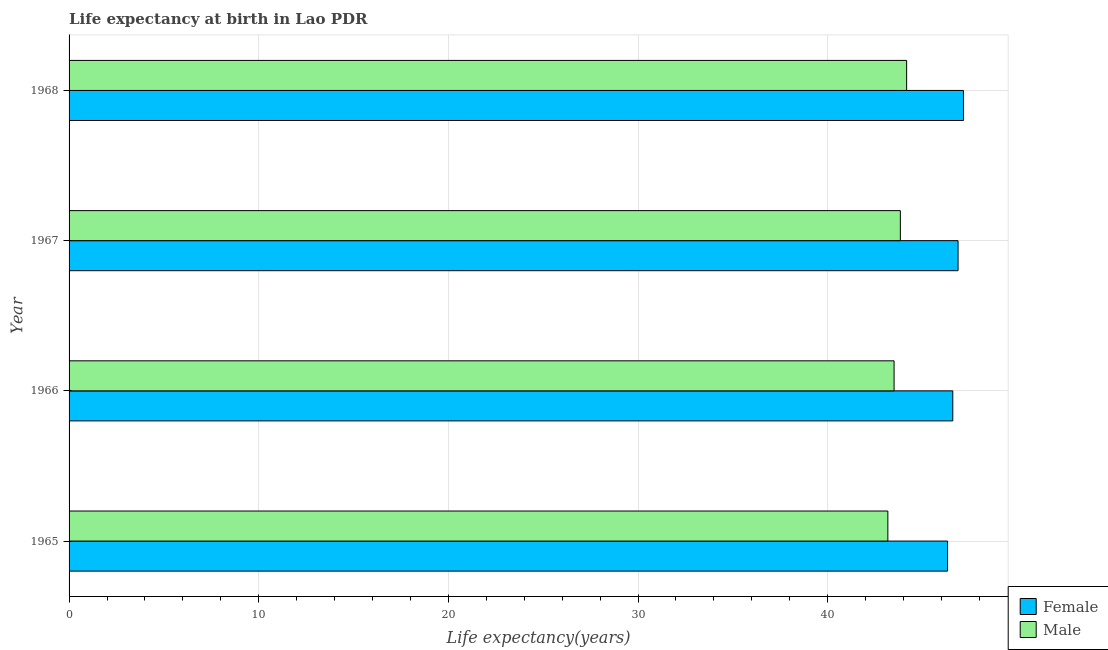How many different coloured bars are there?
Provide a short and direct response. 2. Are the number of bars per tick equal to the number of legend labels?
Offer a terse response. Yes. Are the number of bars on each tick of the Y-axis equal?
Offer a very short reply. Yes. What is the label of the 1st group of bars from the top?
Keep it short and to the point. 1968. In how many cases, is the number of bars for a given year not equal to the number of legend labels?
Make the answer very short. 0. What is the life expectancy(male) in 1968?
Your answer should be compact. 44.16. Across all years, what is the maximum life expectancy(female)?
Your response must be concise. 47.16. Across all years, what is the minimum life expectancy(female)?
Your answer should be compact. 46.32. In which year was the life expectancy(female) maximum?
Provide a short and direct response. 1968. In which year was the life expectancy(female) minimum?
Give a very brief answer. 1965. What is the total life expectancy(male) in the graph?
Your answer should be compact. 174.67. What is the difference between the life expectancy(male) in 1966 and that in 1968?
Provide a succinct answer. -0.66. What is the difference between the life expectancy(male) in 1966 and the life expectancy(female) in 1967?
Keep it short and to the point. -3.37. What is the average life expectancy(female) per year?
Make the answer very short. 46.74. In the year 1967, what is the difference between the life expectancy(female) and life expectancy(male)?
Ensure brevity in your answer.  3.04. In how many years, is the life expectancy(female) greater than 2 years?
Your answer should be compact. 4. Is the difference between the life expectancy(male) in 1966 and 1967 greater than the difference between the life expectancy(female) in 1966 and 1967?
Give a very brief answer. No. What is the difference between the highest and the second highest life expectancy(male)?
Your answer should be very brief. 0.33. What is the difference between the highest and the lowest life expectancy(male)?
Keep it short and to the point. 0.99. In how many years, is the life expectancy(male) greater than the average life expectancy(male) taken over all years?
Ensure brevity in your answer.  2. Is the sum of the life expectancy(male) in 1965 and 1966 greater than the maximum life expectancy(female) across all years?
Provide a short and direct response. Yes. How many bars are there?
Provide a succinct answer. 8. Are all the bars in the graph horizontal?
Provide a short and direct response. Yes. How many years are there in the graph?
Make the answer very short. 4. What is the difference between two consecutive major ticks on the X-axis?
Ensure brevity in your answer.  10. Are the values on the major ticks of X-axis written in scientific E-notation?
Offer a terse response. No. How many legend labels are there?
Your answer should be compact. 2. How are the legend labels stacked?
Make the answer very short. Vertical. What is the title of the graph?
Your answer should be very brief. Life expectancy at birth in Lao PDR. What is the label or title of the X-axis?
Give a very brief answer. Life expectancy(years). What is the Life expectancy(years) in Female in 1965?
Give a very brief answer. 46.32. What is the Life expectancy(years) of Male in 1965?
Your answer should be very brief. 43.17. What is the Life expectancy(years) of Female in 1966?
Keep it short and to the point. 46.6. What is the Life expectancy(years) of Male in 1966?
Offer a very short reply. 43.5. What is the Life expectancy(years) in Female in 1967?
Provide a succinct answer. 46.88. What is the Life expectancy(years) of Male in 1967?
Make the answer very short. 43.83. What is the Life expectancy(years) of Female in 1968?
Your answer should be very brief. 47.16. What is the Life expectancy(years) in Male in 1968?
Ensure brevity in your answer.  44.16. Across all years, what is the maximum Life expectancy(years) of Female?
Ensure brevity in your answer.  47.16. Across all years, what is the maximum Life expectancy(years) in Male?
Make the answer very short. 44.16. Across all years, what is the minimum Life expectancy(years) in Female?
Your answer should be compact. 46.32. Across all years, what is the minimum Life expectancy(years) of Male?
Ensure brevity in your answer.  43.17. What is the total Life expectancy(years) in Female in the graph?
Your answer should be very brief. 186.96. What is the total Life expectancy(years) in Male in the graph?
Ensure brevity in your answer.  174.67. What is the difference between the Life expectancy(years) in Female in 1965 and that in 1966?
Your answer should be very brief. -0.28. What is the difference between the Life expectancy(years) in Male in 1965 and that in 1966?
Offer a very short reply. -0.33. What is the difference between the Life expectancy(years) of Female in 1965 and that in 1967?
Provide a short and direct response. -0.55. What is the difference between the Life expectancy(years) in Male in 1965 and that in 1967?
Your answer should be compact. -0.66. What is the difference between the Life expectancy(years) in Female in 1965 and that in 1968?
Your response must be concise. -0.84. What is the difference between the Life expectancy(years) of Male in 1965 and that in 1968?
Provide a succinct answer. -0.99. What is the difference between the Life expectancy(years) of Female in 1966 and that in 1967?
Give a very brief answer. -0.28. What is the difference between the Life expectancy(years) of Male in 1966 and that in 1967?
Your answer should be compact. -0.33. What is the difference between the Life expectancy(years) in Female in 1966 and that in 1968?
Your response must be concise. -0.56. What is the difference between the Life expectancy(years) in Male in 1966 and that in 1968?
Offer a very short reply. -0.66. What is the difference between the Life expectancy(years) of Female in 1967 and that in 1968?
Your answer should be compact. -0.28. What is the difference between the Life expectancy(years) of Male in 1967 and that in 1968?
Give a very brief answer. -0.33. What is the difference between the Life expectancy(years) of Female in 1965 and the Life expectancy(years) of Male in 1966?
Your response must be concise. 2.82. What is the difference between the Life expectancy(years) in Female in 1965 and the Life expectancy(years) in Male in 1967?
Your response must be concise. 2.49. What is the difference between the Life expectancy(years) of Female in 1965 and the Life expectancy(years) of Male in 1968?
Offer a terse response. 2.16. What is the difference between the Life expectancy(years) in Female in 1966 and the Life expectancy(years) in Male in 1967?
Give a very brief answer. 2.77. What is the difference between the Life expectancy(years) in Female in 1966 and the Life expectancy(years) in Male in 1968?
Your answer should be compact. 2.43. What is the difference between the Life expectancy(years) in Female in 1967 and the Life expectancy(years) in Male in 1968?
Your answer should be compact. 2.71. What is the average Life expectancy(years) in Female per year?
Provide a succinct answer. 46.74. What is the average Life expectancy(years) of Male per year?
Offer a terse response. 43.67. In the year 1965, what is the difference between the Life expectancy(years) of Female and Life expectancy(years) of Male?
Ensure brevity in your answer.  3.15. In the year 1966, what is the difference between the Life expectancy(years) in Female and Life expectancy(years) in Male?
Your answer should be very brief. 3.1. In the year 1967, what is the difference between the Life expectancy(years) of Female and Life expectancy(years) of Male?
Provide a short and direct response. 3.04. In the year 1968, what is the difference between the Life expectancy(years) in Female and Life expectancy(years) in Male?
Ensure brevity in your answer.  3. What is the ratio of the Life expectancy(years) in Female in 1965 to that in 1966?
Give a very brief answer. 0.99. What is the ratio of the Life expectancy(years) of Female in 1965 to that in 1967?
Make the answer very short. 0.99. What is the ratio of the Life expectancy(years) of Male in 1965 to that in 1967?
Provide a succinct answer. 0.98. What is the ratio of the Life expectancy(years) in Female in 1965 to that in 1968?
Make the answer very short. 0.98. What is the ratio of the Life expectancy(years) in Male in 1965 to that in 1968?
Ensure brevity in your answer.  0.98. What is the ratio of the Life expectancy(years) in Female in 1966 to that in 1967?
Make the answer very short. 0.99. What is the ratio of the Life expectancy(years) of Female in 1966 to that in 1968?
Provide a short and direct response. 0.99. What is the ratio of the Life expectancy(years) of Male in 1966 to that in 1968?
Your answer should be compact. 0.98. What is the ratio of the Life expectancy(years) of Female in 1967 to that in 1968?
Provide a succinct answer. 0.99. What is the ratio of the Life expectancy(years) of Male in 1967 to that in 1968?
Ensure brevity in your answer.  0.99. What is the difference between the highest and the second highest Life expectancy(years) in Female?
Ensure brevity in your answer.  0.28. What is the difference between the highest and the second highest Life expectancy(years) in Male?
Your answer should be compact. 0.33. What is the difference between the highest and the lowest Life expectancy(years) in Female?
Provide a short and direct response. 0.84. 